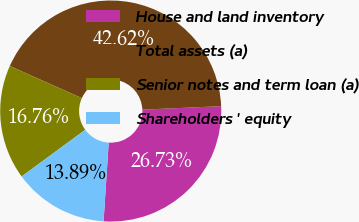Convert chart to OTSL. <chart><loc_0><loc_0><loc_500><loc_500><pie_chart><fcel>House and land inventory<fcel>Total assets (a)<fcel>Senior notes and term loan (a)<fcel>Shareholders ' equity<nl><fcel>26.73%<fcel>42.62%<fcel>16.76%<fcel>13.89%<nl></chart> 